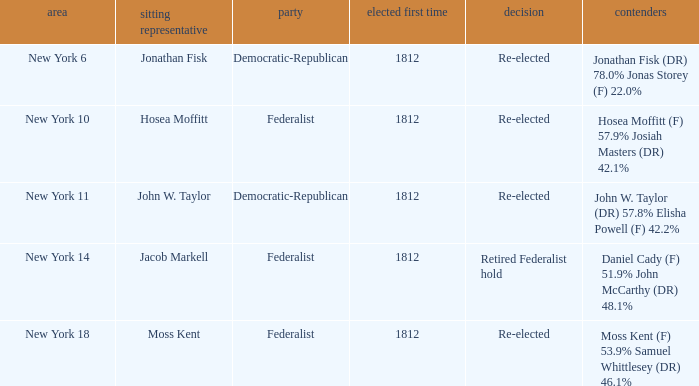Name the first elected for jacob markell 1812.0. 